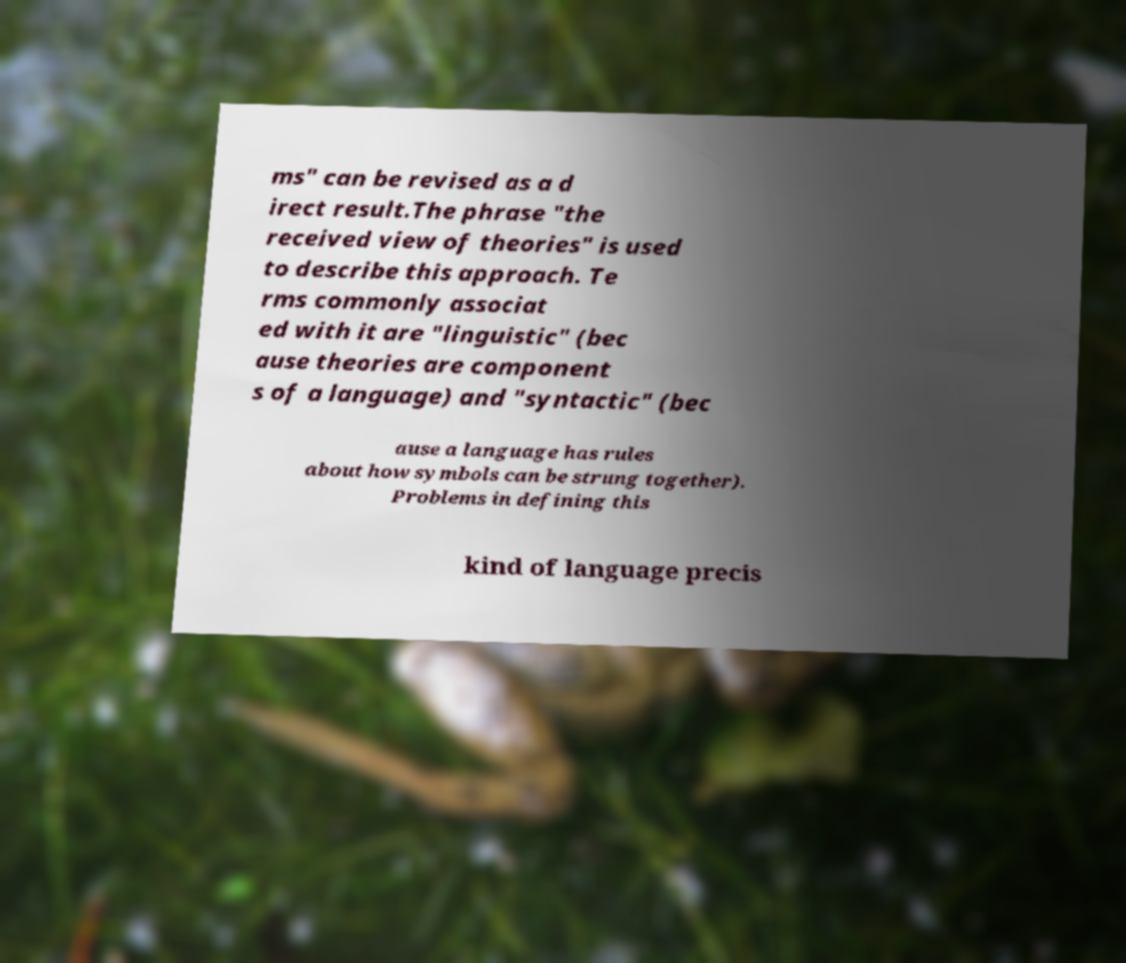Please read and relay the text visible in this image. What does it say? ms" can be revised as a d irect result.The phrase "the received view of theories" is used to describe this approach. Te rms commonly associat ed with it are "linguistic" (bec ause theories are component s of a language) and "syntactic" (bec ause a language has rules about how symbols can be strung together). Problems in defining this kind of language precis 